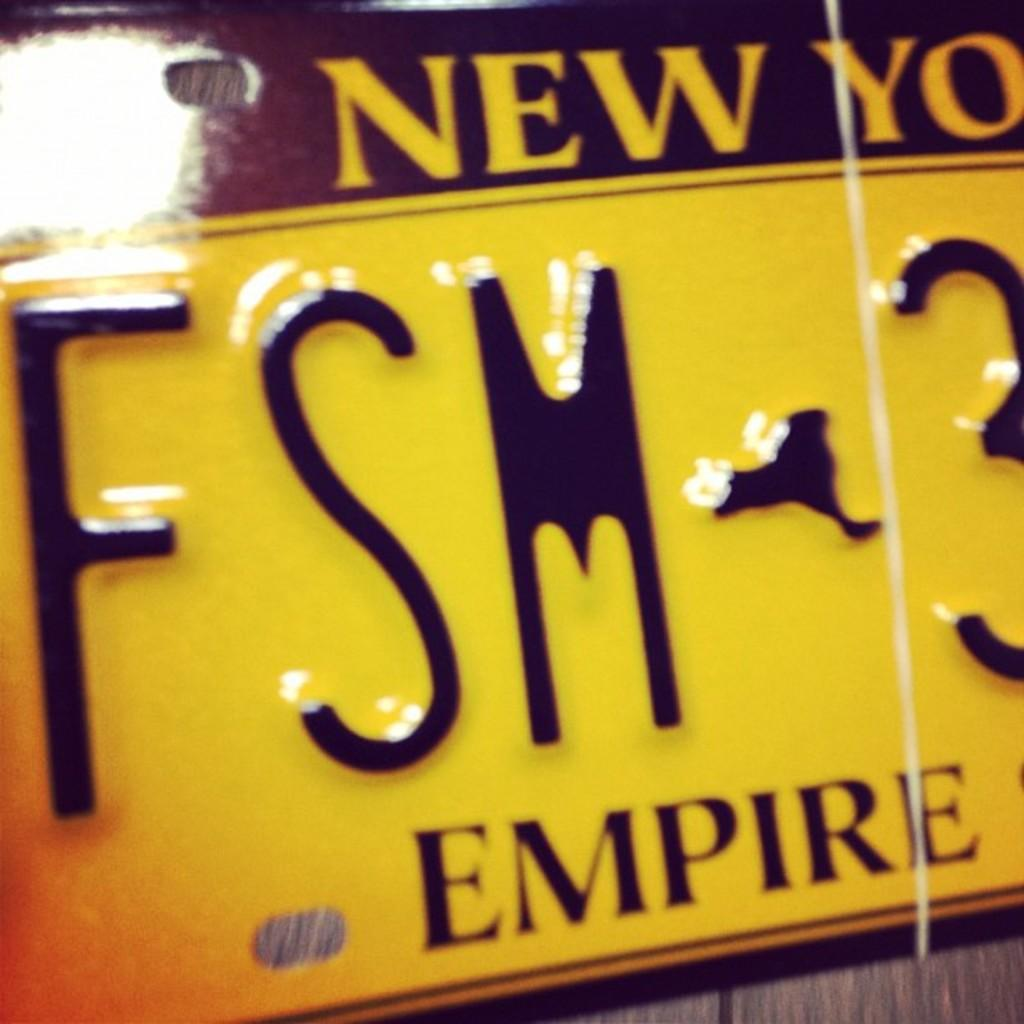What is the main object in the image? There is a board in the image. What colors are used on the board? The board has a black and yellow color pattern. What can be found on the board? There is writing on the board. What is the board placed on? The board is on a brown color surface. How many roses are on the board in the image? There are no roses present on the board in the image. Can you describe the holiday being celebrated in the image? There is no holiday being celebrated in the image; it only features a board with a black and yellow color pattern and writing. 